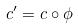Convert formula to latex. <formula><loc_0><loc_0><loc_500><loc_500>c ^ { \prime } = c \circ \phi</formula> 